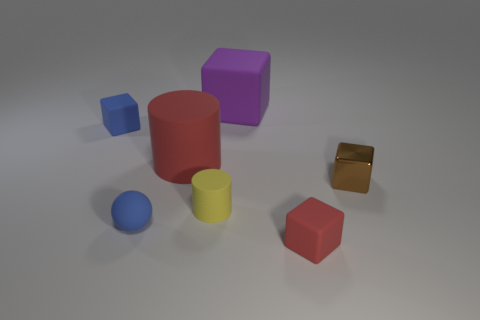Subtract all large purple cubes. How many cubes are left? 3 Subtract all cylinders. How many objects are left? 5 Subtract all large red objects. Subtract all red matte things. How many objects are left? 4 Add 3 tiny blue things. How many tiny blue things are left? 5 Add 7 gray shiny cylinders. How many gray shiny cylinders exist? 7 Add 2 purple rubber things. How many objects exist? 9 Subtract all yellow cylinders. How many cylinders are left? 1 Subtract 0 gray balls. How many objects are left? 7 Subtract 1 balls. How many balls are left? 0 Subtract all gray cylinders. Subtract all green spheres. How many cylinders are left? 2 